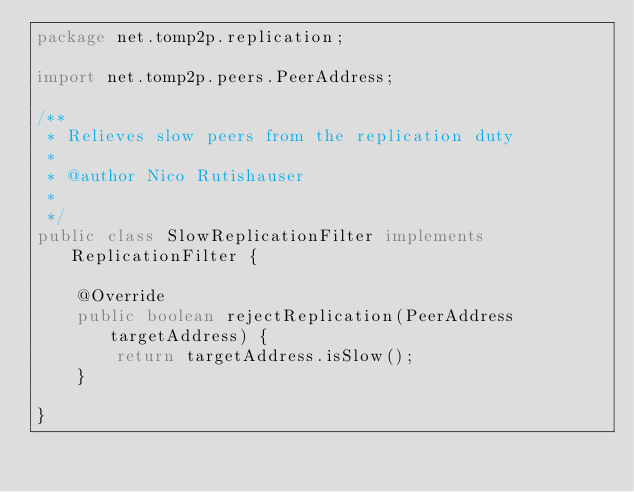Convert code to text. <code><loc_0><loc_0><loc_500><loc_500><_Java_>package net.tomp2p.replication;

import net.tomp2p.peers.PeerAddress;

/**
 * Relieves slow peers from the replication duty
 * 
 * @author Nico Rutishauser
 *
 */
public class SlowReplicationFilter implements ReplicationFilter {

	@Override
	public boolean rejectReplication(PeerAddress targetAddress) {
		return targetAddress.isSlow();
	}

}
</code> 